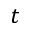<formula> <loc_0><loc_0><loc_500><loc_500>t</formula> 